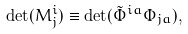<formula> <loc_0><loc_0><loc_500><loc_500>\det ( M ^ { i } _ { j } ) \equiv \det ( \tilde { \Phi } ^ { i a } \Phi _ { j a } ) ,</formula> 